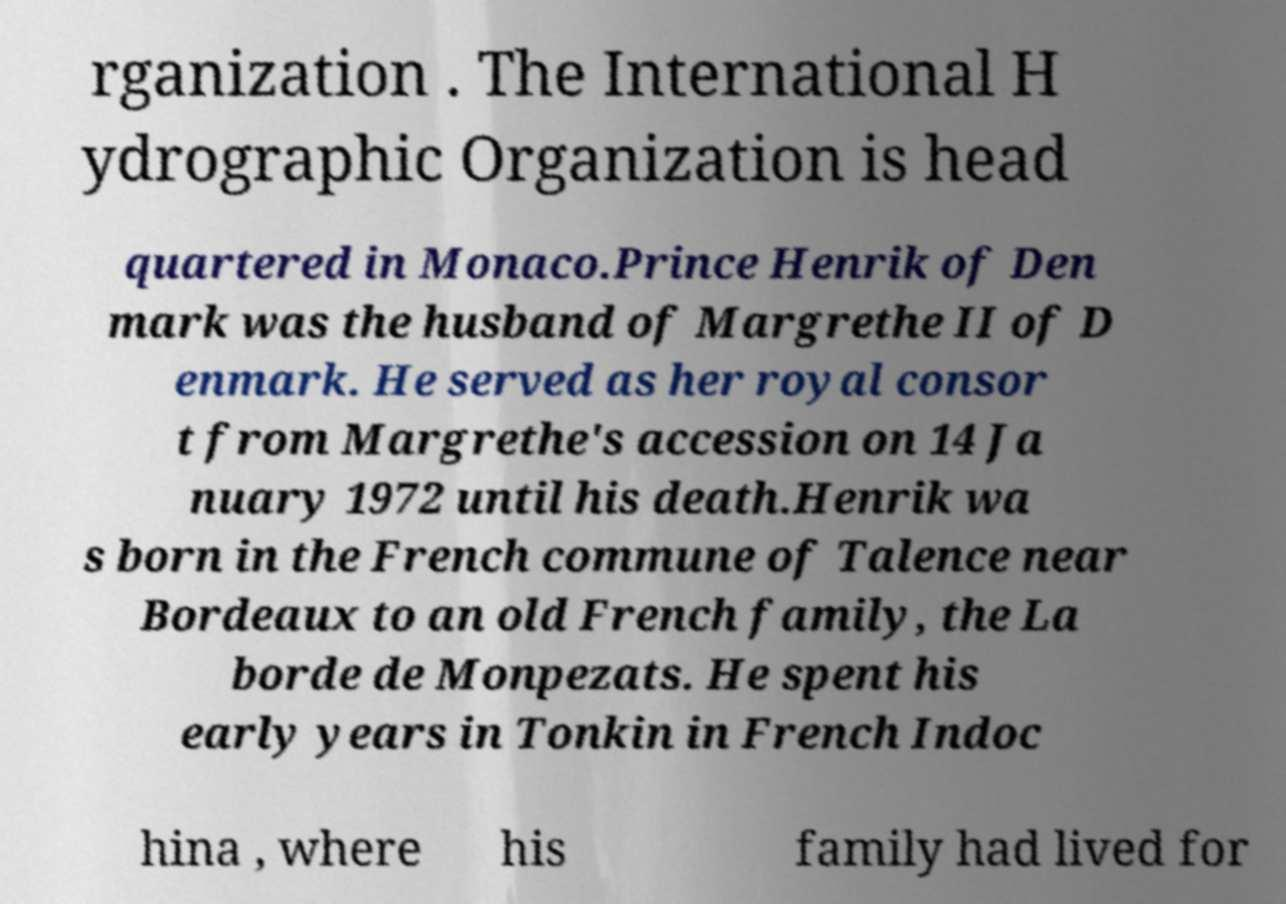Can you read and provide the text displayed in the image?This photo seems to have some interesting text. Can you extract and type it out for me? rganization . The International H ydrographic Organization is head quartered in Monaco.Prince Henrik of Den mark was the husband of Margrethe II of D enmark. He served as her royal consor t from Margrethe's accession on 14 Ja nuary 1972 until his death.Henrik wa s born in the French commune of Talence near Bordeaux to an old French family, the La borde de Monpezats. He spent his early years in Tonkin in French Indoc hina , where his family had lived for 